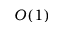Convert formula to latex. <formula><loc_0><loc_0><loc_500><loc_500>O ( 1 )</formula> 